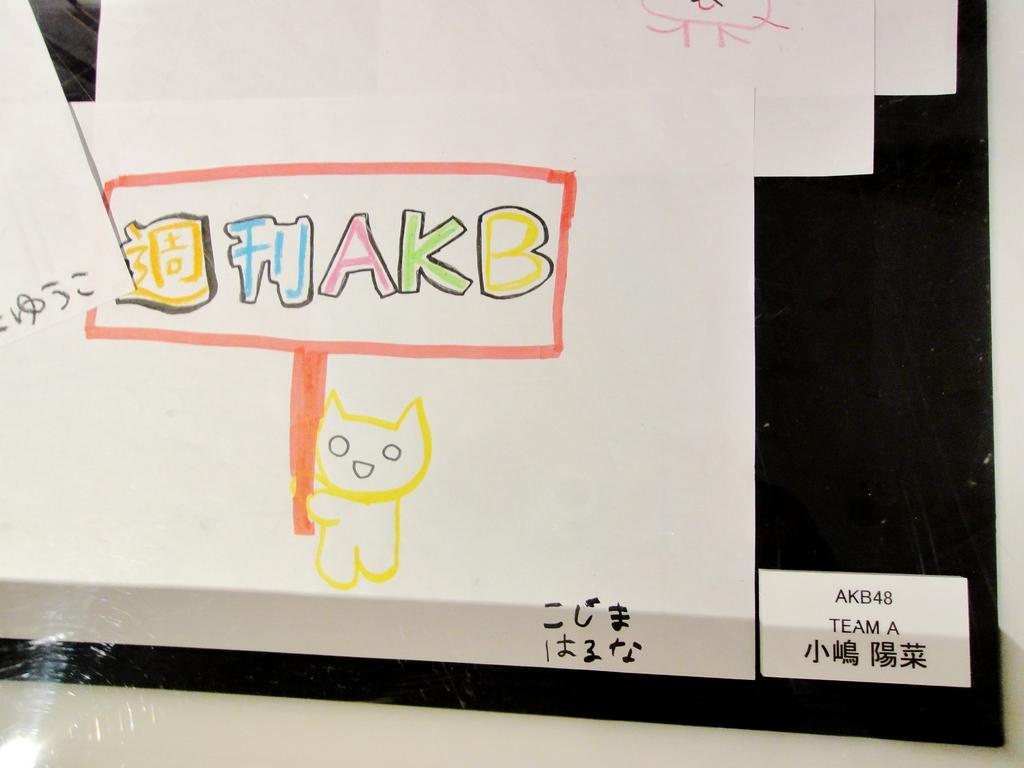What is the main object in the image? There is a board in the image. What can be seen on the board? There are written elements and drawn elements on the board. What type of hobbies are being discussed during the feast in the image? There is no feast or discussion of hobbies present in the image; it only features a board with written and drawn elements. 